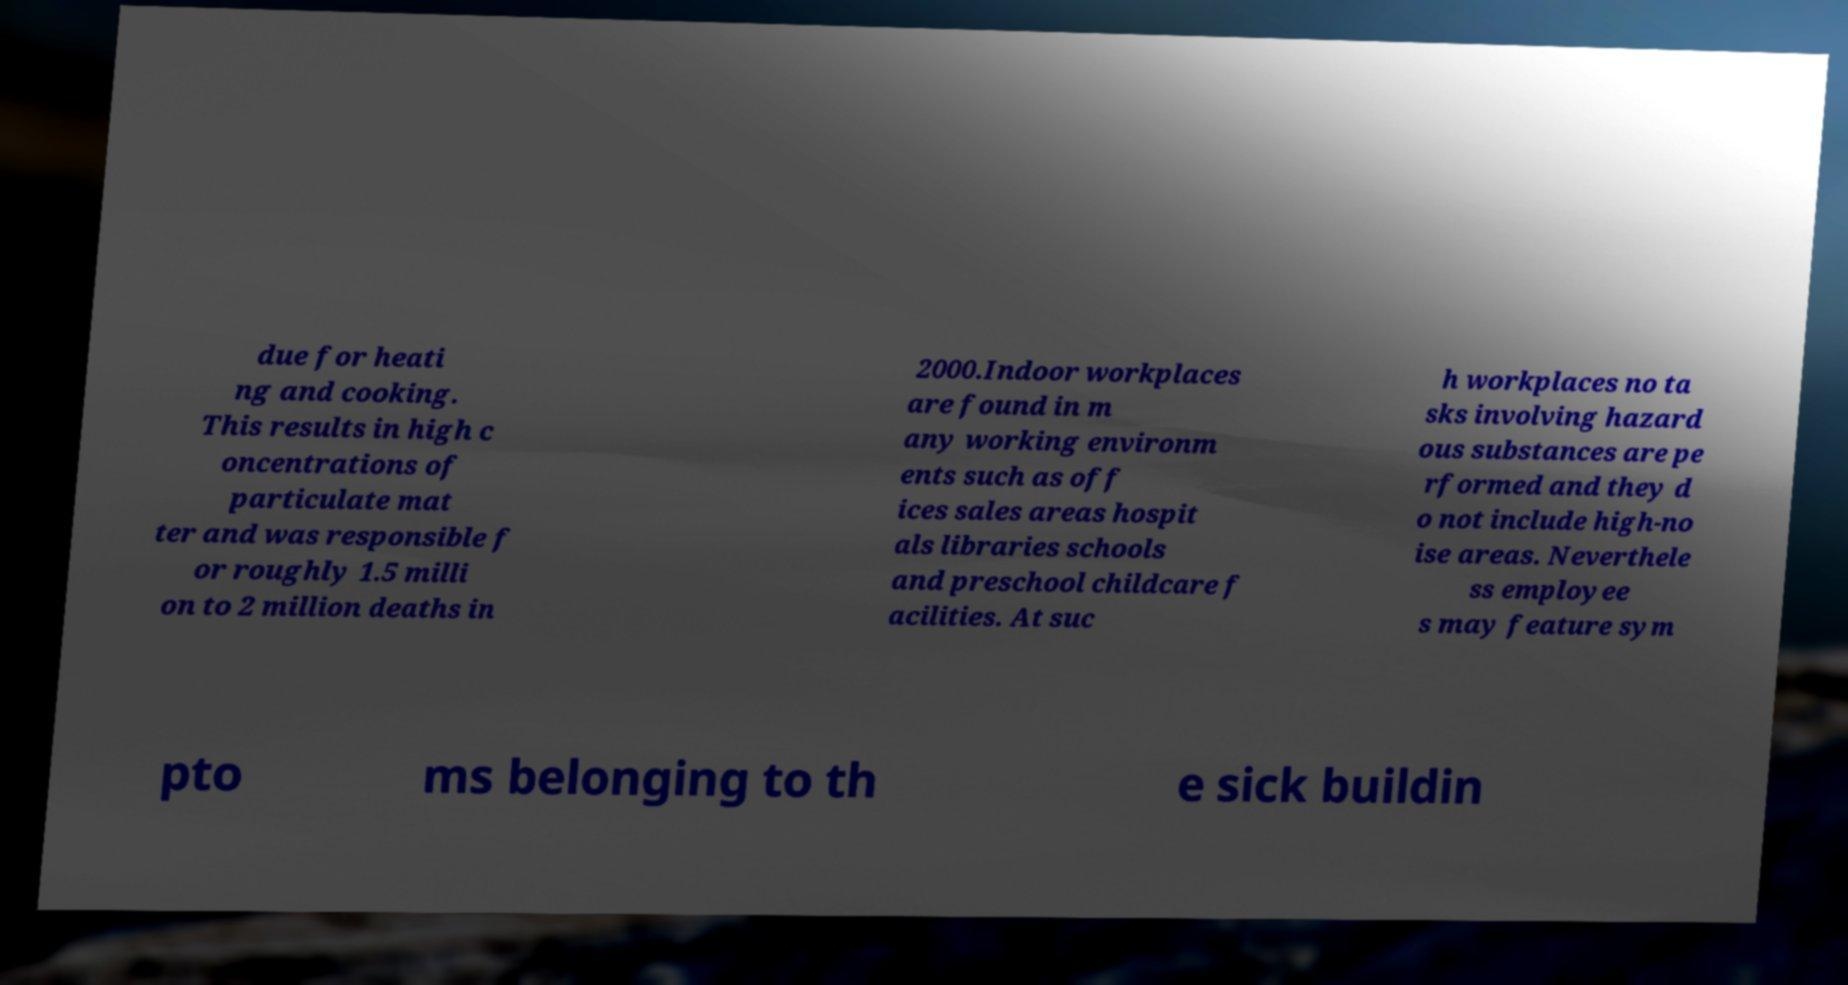For documentation purposes, I need the text within this image transcribed. Could you provide that? due for heati ng and cooking. This results in high c oncentrations of particulate mat ter and was responsible f or roughly 1.5 milli on to 2 million deaths in 2000.Indoor workplaces are found in m any working environm ents such as off ices sales areas hospit als libraries schools and preschool childcare f acilities. At suc h workplaces no ta sks involving hazard ous substances are pe rformed and they d o not include high-no ise areas. Neverthele ss employee s may feature sym pto ms belonging to th e sick buildin 